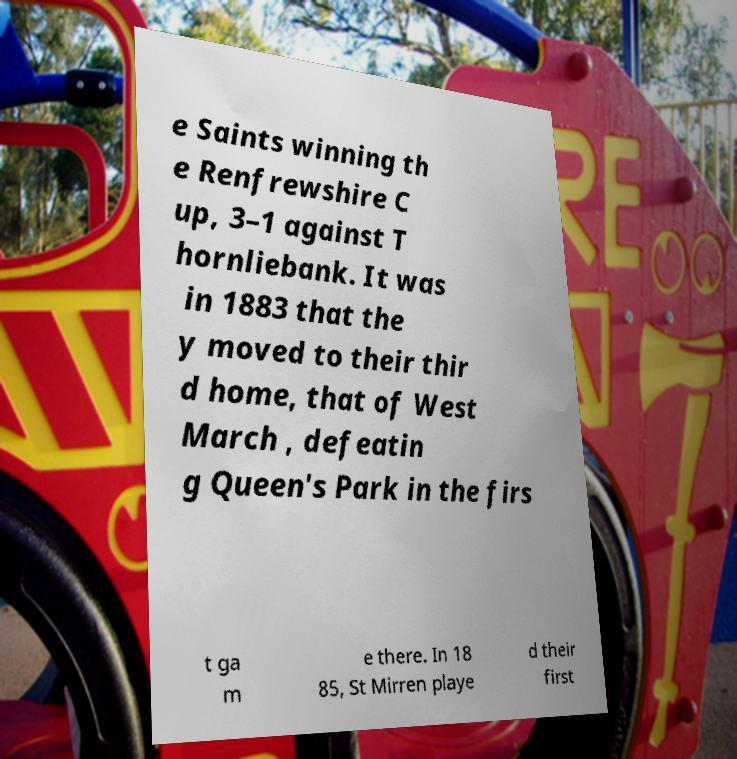I need the written content from this picture converted into text. Can you do that? e Saints winning th e Renfrewshire C up, 3–1 against T hornliebank. It was in 1883 that the y moved to their thir d home, that of West March , defeatin g Queen's Park in the firs t ga m e there. In 18 85, St Mirren playe d their first 